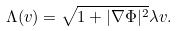Convert formula to latex. <formula><loc_0><loc_0><loc_500><loc_500>\Lambda ( v ) = \sqrt { 1 + | \nabla \Phi | ^ { 2 } } \lambda v .</formula> 